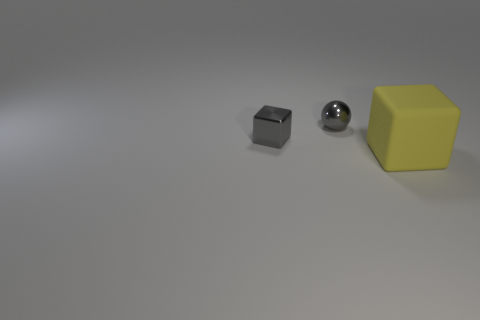There is a metallic cube that is the same size as the metal sphere; what color is it? gray 